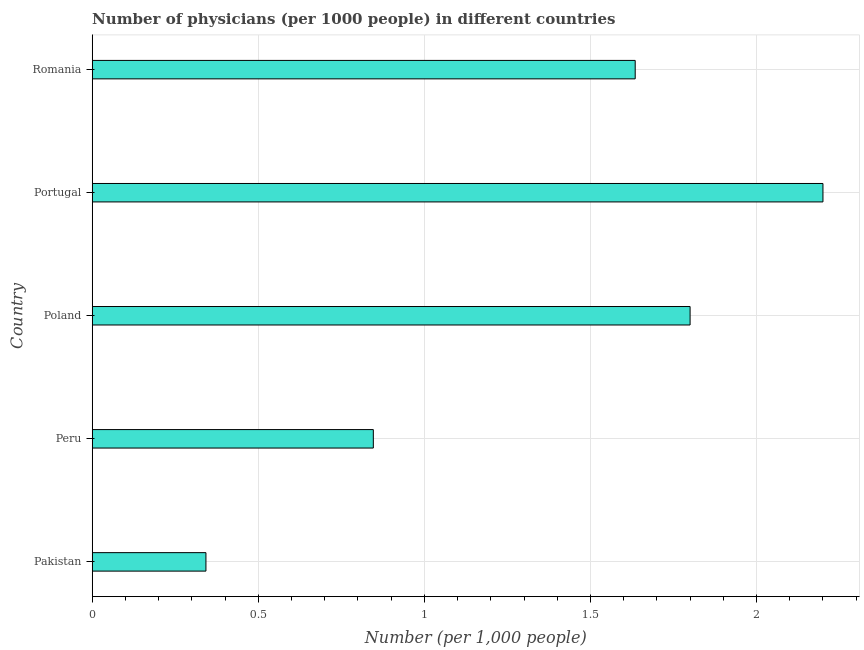What is the title of the graph?
Ensure brevity in your answer.  Number of physicians (per 1000 people) in different countries. What is the label or title of the X-axis?
Give a very brief answer. Number (per 1,0 people). What is the number of physicians in Romania?
Provide a succinct answer. 1.63. Across all countries, what is the minimum number of physicians?
Make the answer very short. 0.34. What is the sum of the number of physicians?
Keep it short and to the point. 6.82. What is the difference between the number of physicians in Portugal and Romania?
Offer a terse response. 0.56. What is the average number of physicians per country?
Offer a very short reply. 1.36. What is the median number of physicians?
Give a very brief answer. 1.63. What is the ratio of the number of physicians in Pakistan to that in Poland?
Give a very brief answer. 0.19. Is the number of physicians in Peru less than that in Poland?
Your response must be concise. Yes. Is the difference between the number of physicians in Poland and Portugal greater than the difference between any two countries?
Ensure brevity in your answer.  No. What is the difference between the highest and the lowest number of physicians?
Ensure brevity in your answer.  1.86. In how many countries, is the number of physicians greater than the average number of physicians taken over all countries?
Your answer should be compact. 3. How many bars are there?
Ensure brevity in your answer.  5. Are all the bars in the graph horizontal?
Your answer should be very brief. Yes. What is the difference between two consecutive major ticks on the X-axis?
Provide a succinct answer. 0.5. Are the values on the major ticks of X-axis written in scientific E-notation?
Provide a succinct answer. No. What is the Number (per 1,000 people) of Pakistan?
Provide a succinct answer. 0.34. What is the Number (per 1,000 people) in Peru?
Ensure brevity in your answer.  0.85. What is the Number (per 1,000 people) of Poland?
Offer a terse response. 1.8. What is the Number (per 1,000 people) in Romania?
Give a very brief answer. 1.63. What is the difference between the Number (per 1,000 people) in Pakistan and Peru?
Make the answer very short. -0.5. What is the difference between the Number (per 1,000 people) in Pakistan and Poland?
Keep it short and to the point. -1.46. What is the difference between the Number (per 1,000 people) in Pakistan and Portugal?
Give a very brief answer. -1.86. What is the difference between the Number (per 1,000 people) in Pakistan and Romania?
Your answer should be very brief. -1.29. What is the difference between the Number (per 1,000 people) in Peru and Poland?
Ensure brevity in your answer.  -0.95. What is the difference between the Number (per 1,000 people) in Peru and Portugal?
Give a very brief answer. -1.35. What is the difference between the Number (per 1,000 people) in Peru and Romania?
Ensure brevity in your answer.  -0.79. What is the difference between the Number (per 1,000 people) in Poland and Portugal?
Your response must be concise. -0.4. What is the difference between the Number (per 1,000 people) in Poland and Romania?
Your answer should be compact. 0.17. What is the difference between the Number (per 1,000 people) in Portugal and Romania?
Keep it short and to the point. 0.57. What is the ratio of the Number (per 1,000 people) in Pakistan to that in Peru?
Offer a terse response. 0.4. What is the ratio of the Number (per 1,000 people) in Pakistan to that in Poland?
Provide a succinct answer. 0.19. What is the ratio of the Number (per 1,000 people) in Pakistan to that in Portugal?
Keep it short and to the point. 0.16. What is the ratio of the Number (per 1,000 people) in Pakistan to that in Romania?
Provide a succinct answer. 0.21. What is the ratio of the Number (per 1,000 people) in Peru to that in Poland?
Provide a short and direct response. 0.47. What is the ratio of the Number (per 1,000 people) in Peru to that in Portugal?
Make the answer very short. 0.39. What is the ratio of the Number (per 1,000 people) in Peru to that in Romania?
Provide a succinct answer. 0.52. What is the ratio of the Number (per 1,000 people) in Poland to that in Portugal?
Your answer should be compact. 0.82. What is the ratio of the Number (per 1,000 people) in Poland to that in Romania?
Your answer should be very brief. 1.1. What is the ratio of the Number (per 1,000 people) in Portugal to that in Romania?
Make the answer very short. 1.35. 